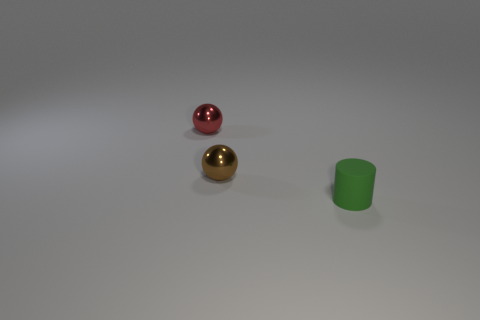Add 2 tiny red blocks. How many objects exist? 5 Subtract all balls. How many objects are left? 1 Subtract all tiny gray metal balls. Subtract all tiny red metallic things. How many objects are left? 2 Add 2 tiny brown things. How many tiny brown things are left? 3 Add 2 large brown cubes. How many large brown cubes exist? 2 Subtract 1 red spheres. How many objects are left? 2 